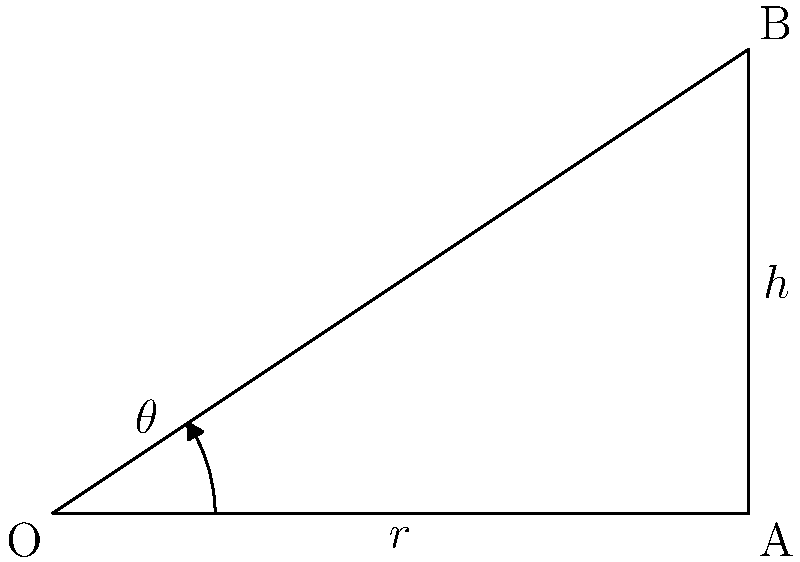In the diagram, OA represents the tonearm of a record player, and OB represents the optimal position for playback. If the radius of the record (r) is 6 inches and the height of the tonearm pivot (h) is 4 inches, what is the optimal angle $\theta$ (in degrees) for the tonearm? To find the optimal angle for the tonearm, we need to use trigonometry. Let's follow these steps:

1) In the right triangle OAB:
   - OA is the radius (r) = 6 inches
   - AB is the height (h) = 4 inches
   - OB is the hypotenuse

2) We can use the tangent function to find the angle $\theta$:

   $\tan(\theta) = \frac{\text{opposite}}{\text{adjacent}} = \frac{h}{r} = \frac{4}{6}$

3) To get the angle, we need to use the inverse tangent (arctan or $\tan^{-1}$):

   $\theta = \tan^{-1}(\frac{4}{6})$

4) Simplify the fraction:
   
   $\theta = \tan^{-1}(\frac{2}{3})$

5) Calculate this value:

   $\theta \approx 33.69$ degrees

6) Round to two decimal places:

   $\theta \approx 33.69$ degrees

This angle ensures that the tonearm is positioned optimally for playback, balancing the tracking force and minimizing distortion.
Answer: 33.69° 